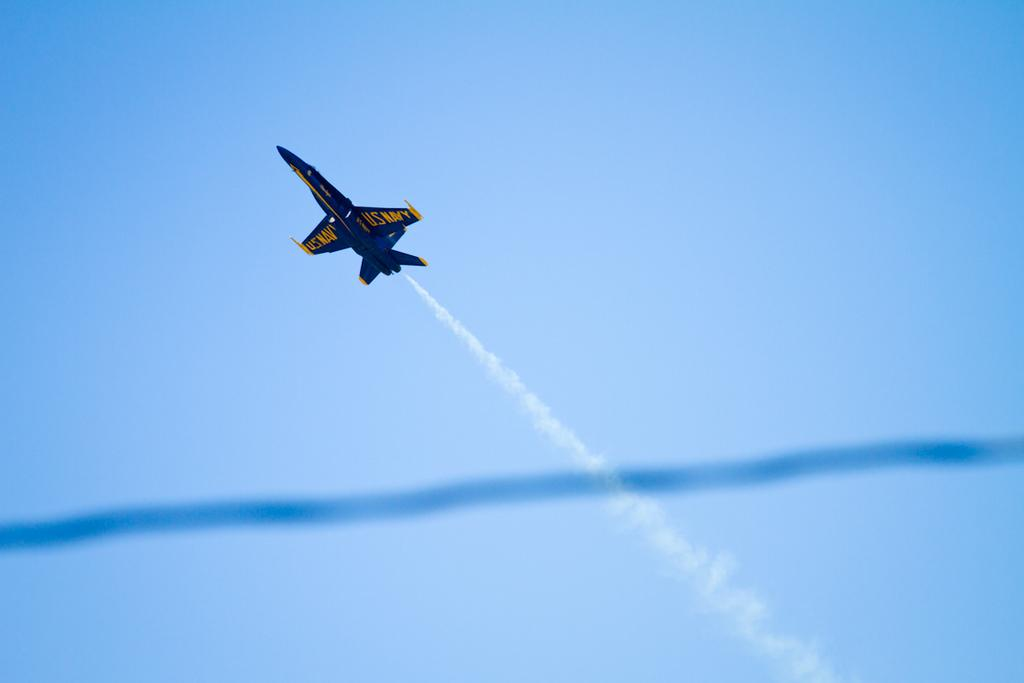What is the main subject of the image? The main subject of the image is an aeroplane. What is the aeroplane doing in the image? The aeroplane is flying in the sky. How many goldfish are swimming in the aeroplane's cockpit in the image? There are no goldfish present in the image, as it features an aeroplane flying in the sky. 